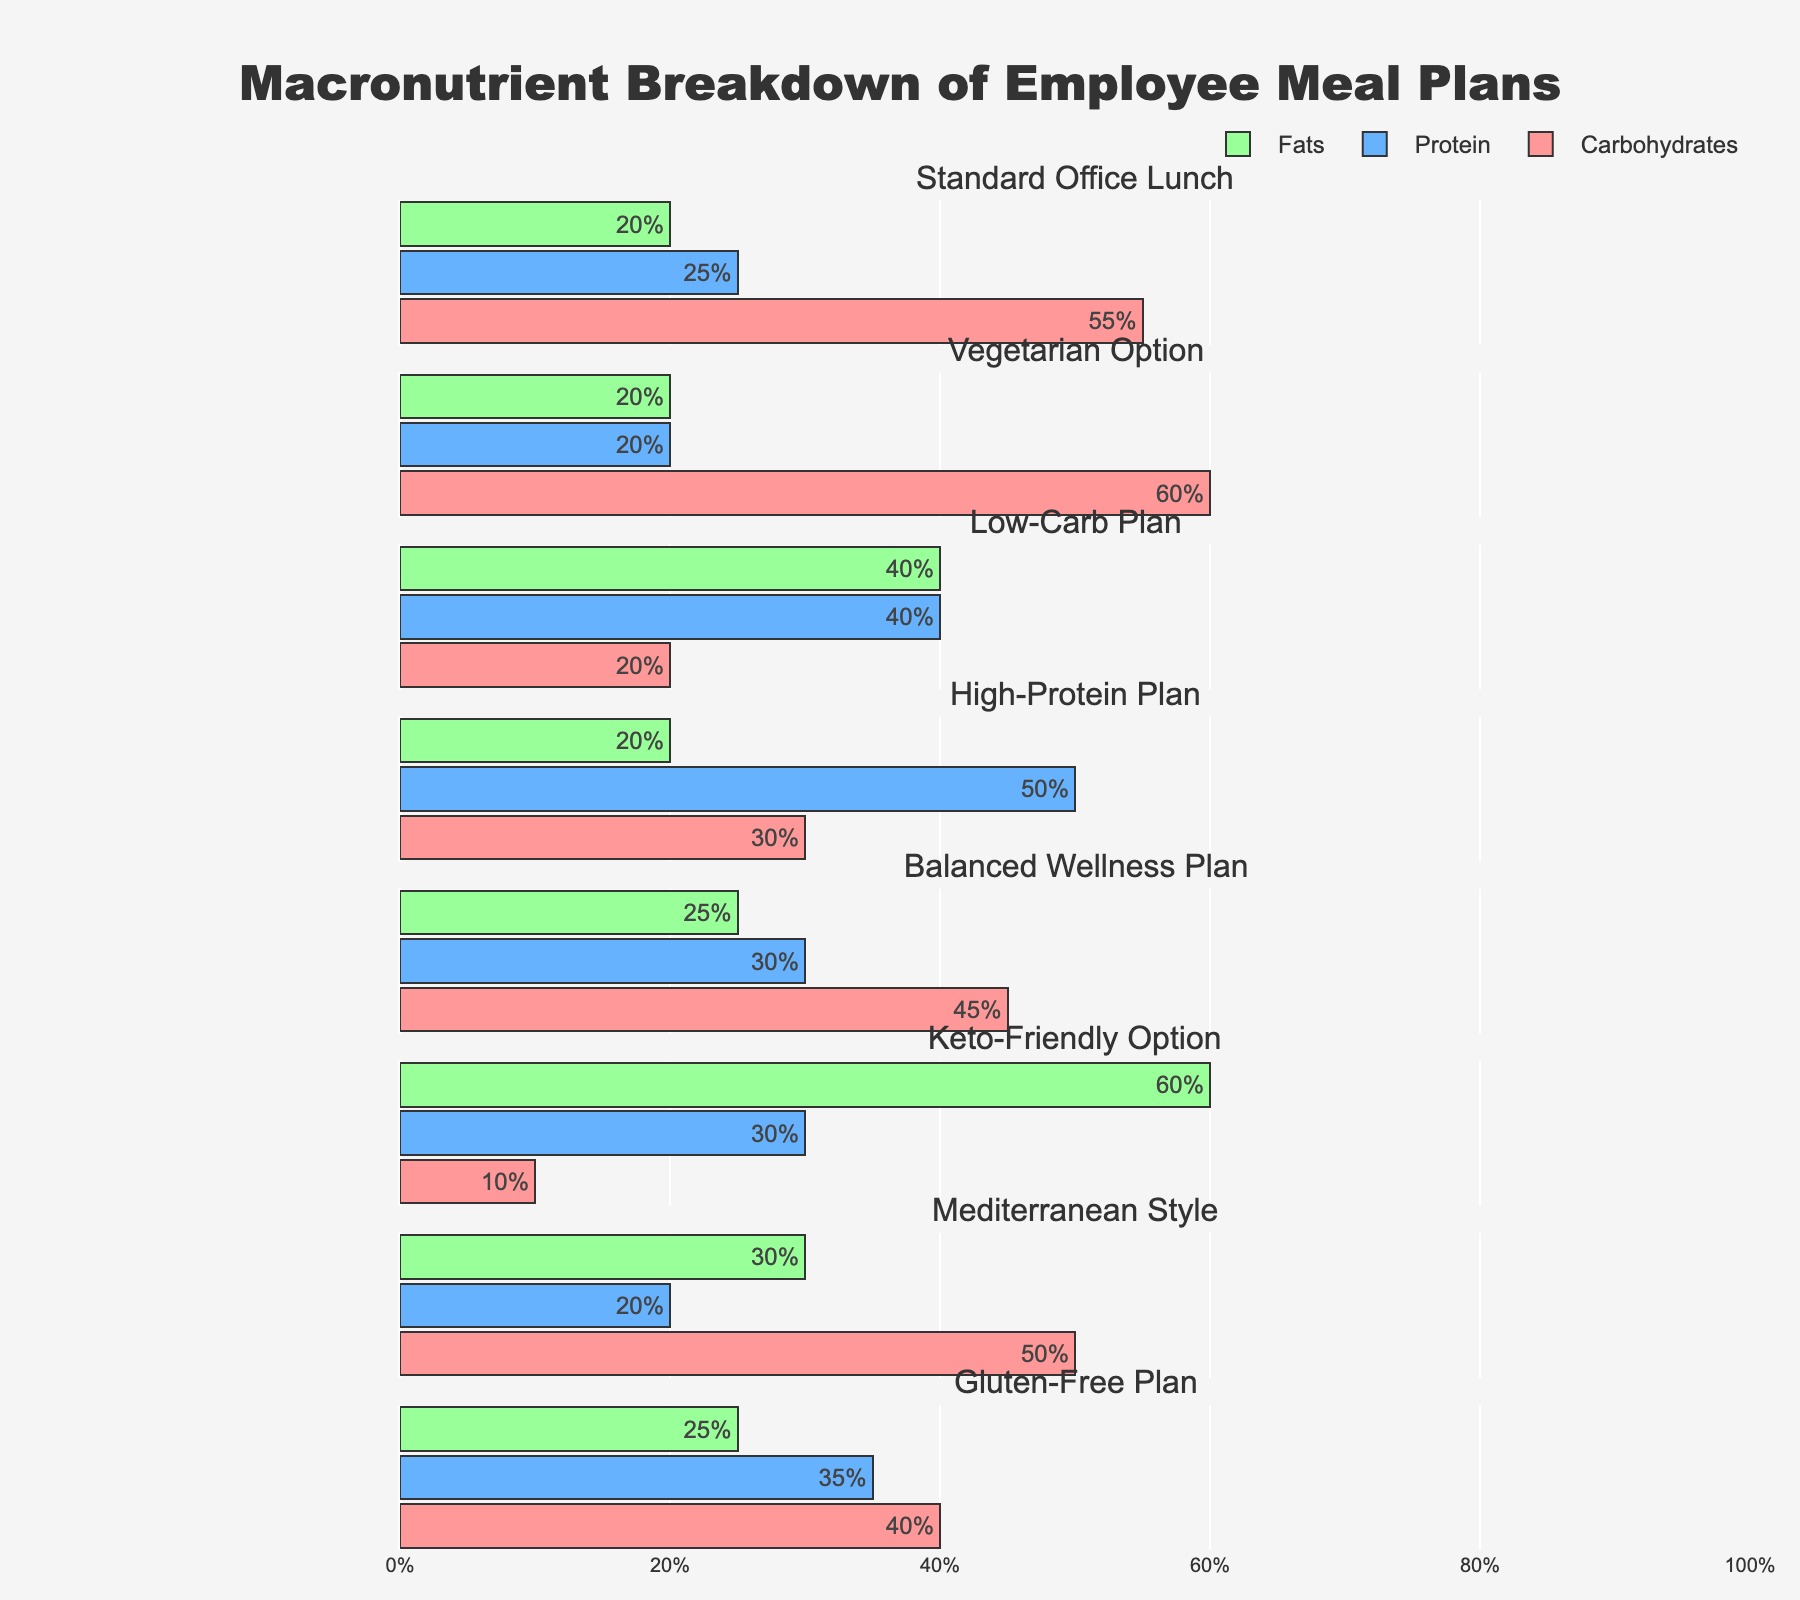What's the title of the figure? The title is usually displayed at the top of the chart and explains what the figure is about. Here, the title "Macronutrient Breakdown of Employee Meal Plans" is clearly visible at the top.
Answer: Macronutrient Breakdown of Employee Meal Plans How many different meal plans are displayed in the figure? The number of subplots corresponds to the number of meal plans since each subplot represents a different meal plan. By counting the subplot titles, we can see that there are 8.
Answer: 8 Which meal plan has the highest percentage of carbohydrates? By observing all the bars representing carbohydrates across the subplots, we can see that the "Vegetarian Option" has the highest percentage at 60%.
Answer: Vegetarian Option Compare the carbohydrate percentage in the "Low-Carb Plan" and the "Keto-Friendly Option". Which one is higher? The "Low-Carb Plan" has carbohydrates at 20%, and the "Keto-Friendly Option" has carbohydrates at 10%. Comparing these two values, 20% is higher than 10%.
Answer: Low-Carb Plan What is the average percentage of protein across all meal plans? To find the average, sum the protein percentages for all meal plans and divide by the number of meal plans. Summing (25 + 20 + 40 + 50 + 30 + 30 + 20 + 35) = 250, then dividing by 8 gives 250 / 8 = 31.25%.
Answer: 31.25% Which meal plan has the highest percentage of fats, and what is that percentage? By scanning the fat percentages displayed in the figure, the "Keto-Friendly Option" has the highest at 60%.
Answer: Keto-Friendly Option, 60% Is there any meal plan where the carbohydrate percentage is lower than the protein percentage? We need to compare the carbohydrate and protein percentages for each meal plan. The "Low-Carb Plan" (20% carbs, 40% protein) and the "Keto-Friendly Option" (10% carbs, 30% protein) have carbohydrates lower than proteins.
Answer: Yes, Low-Carb Plan and Keto-Friendly Option What is the difference in fat percentage between the "Standard Office Lunch" and the "Mediterranean Style"? The fat percentages are 20% for the "Standard Office Lunch" and 30% for the "Mediterranean Style". The difference is 30% - 20% = 10%.
Answer: 10% How do the macronutrient compositions of the "Balanced Wellness Plan" and the "Gluten-Free Plan" compare? For the "Balanced Wellness Plan" (Carbohydrates: 45%, Protein: 30%, Fats: 25%) and the "Gluten-Free Plan" (Carbohydrates: 40%, Protein: 35%, Fats: 25%), comparing each nutrient: 
- Carbohydrates: 45% vs 40% (Balanced Wellness Plan has more)
- Protein: 30% vs 35% (Gluten-Free Plan has more)
- Fats: Both have 25%.
Answer: The Balanced Wellness Plan is higher in carbohydrates, the Gluten-Free Plan is higher in protein, and both are equal in fats Which meal plan is closest to an even distribution of macronutrients? An even distribution would be around 33% for each nutrient. The "Balanced Wellness Plan" has carbohydrates at 45%, protein at 30%, and fats at 25%, which is closer to an even split compared to others.
Answer: Balanced Wellness Plan 